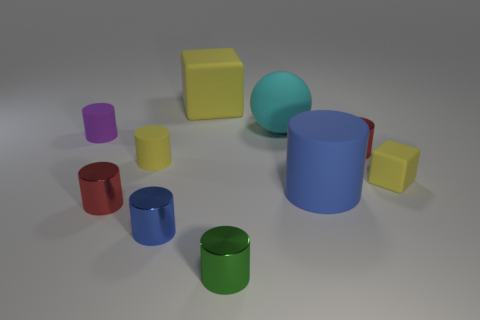There is a yellow object that is both to the left of the blue rubber object and in front of the purple rubber object; what material is it?
Your response must be concise. Rubber. The other cylinder that is the same color as the big matte cylinder is what size?
Provide a short and direct response. Small. How many other objects are there of the same size as the yellow cylinder?
Give a very brief answer. 6. What is the blue thing that is in front of the big rubber cylinder made of?
Keep it short and to the point. Metal. Is the shape of the small purple thing the same as the green metal object?
Your response must be concise. Yes. What number of other things are there of the same shape as the purple rubber thing?
Make the answer very short. 6. What color is the tiny matte object that is on the right side of the blue rubber cylinder?
Give a very brief answer. Yellow. Is the purple rubber cylinder the same size as the ball?
Your answer should be very brief. No. What material is the red cylinder that is right of the rubber cylinder that is on the right side of the yellow cylinder made of?
Your answer should be very brief. Metal. How many tiny rubber things are the same color as the tiny matte cube?
Your answer should be very brief. 1. 